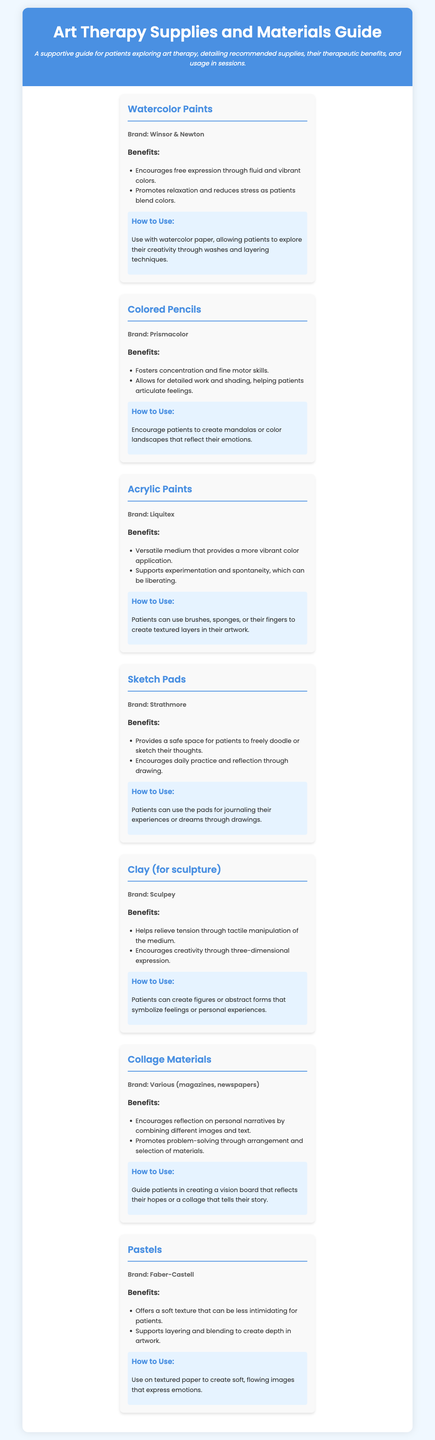What is the title of the document? The title is prominently displayed at the top of the document.
Answer: Art Therapy Supplies and Materials Guide Which brand is associated with watercolor paints? The brand is mentioned directly under the watercolor paints section.
Answer: Winsor & Newton How many types of supplies are listed in the document? The number can be determined by counting the individual supply items in the document.
Answer: Seven What is a benefit of using clay in therapy? The benefits are listed under each supply item, detailing the advantages of using them.
Answer: Helps relieve tension What can patients create with colored pencils? The document specifies activities that patients can engage in using the colored pencils.
Answer: Mandalas or landscapes Which supply encourages problem-solving through arrangement? The document provides the materials that promote various aspects of expression.
Answer: Collage Materials What medium supports layering and blending? The document specifies the type of medium that allows this artistic technique.
Answer: Pastels How should watercolor paints be used to explore creativity? The recommended usage details are found in the "How to Use" section for each item.
Answer: Through washes and layering techniques Which supply is described as versatile? This attribute is highlighted in the benefits section for a specific supply.
Answer: Acrylic Paints 